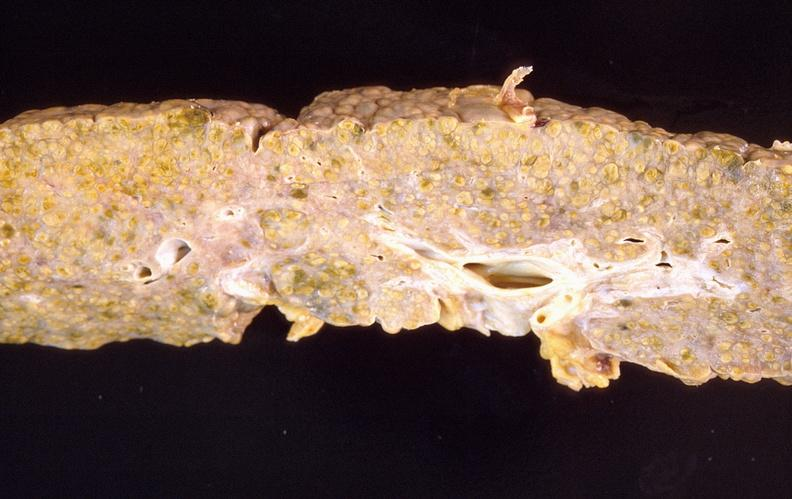does hemorrhagic corpus luteum show liver cirrhosis?
Answer the question using a single word or phrase. No 